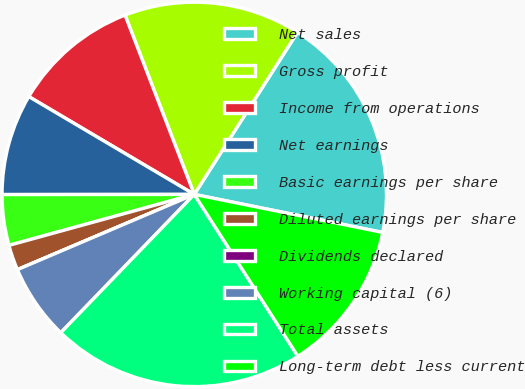<chart> <loc_0><loc_0><loc_500><loc_500><pie_chart><fcel>Net sales<fcel>Gross profit<fcel>Income from operations<fcel>Net earnings<fcel>Basic earnings per share<fcel>Diluted earnings per share<fcel>Dividends declared<fcel>Working capital (6)<fcel>Total assets<fcel>Long-term debt less current<nl><fcel>19.15%<fcel>14.89%<fcel>10.64%<fcel>8.51%<fcel>4.26%<fcel>2.13%<fcel>0.0%<fcel>6.38%<fcel>21.28%<fcel>12.77%<nl></chart> 